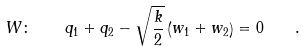<formula> <loc_0><loc_0><loc_500><loc_500>W \colon \quad q _ { 1 } + q _ { 2 } - \sqrt { \frac { k } { 2 } } \left ( w _ { 1 } + w _ { 2 } \right ) = 0 \quad .</formula> 